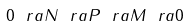Convert formula to latex. <formula><loc_0><loc_0><loc_500><loc_500>0 \ r a N \ r a P \ r a M \ r a 0</formula> 